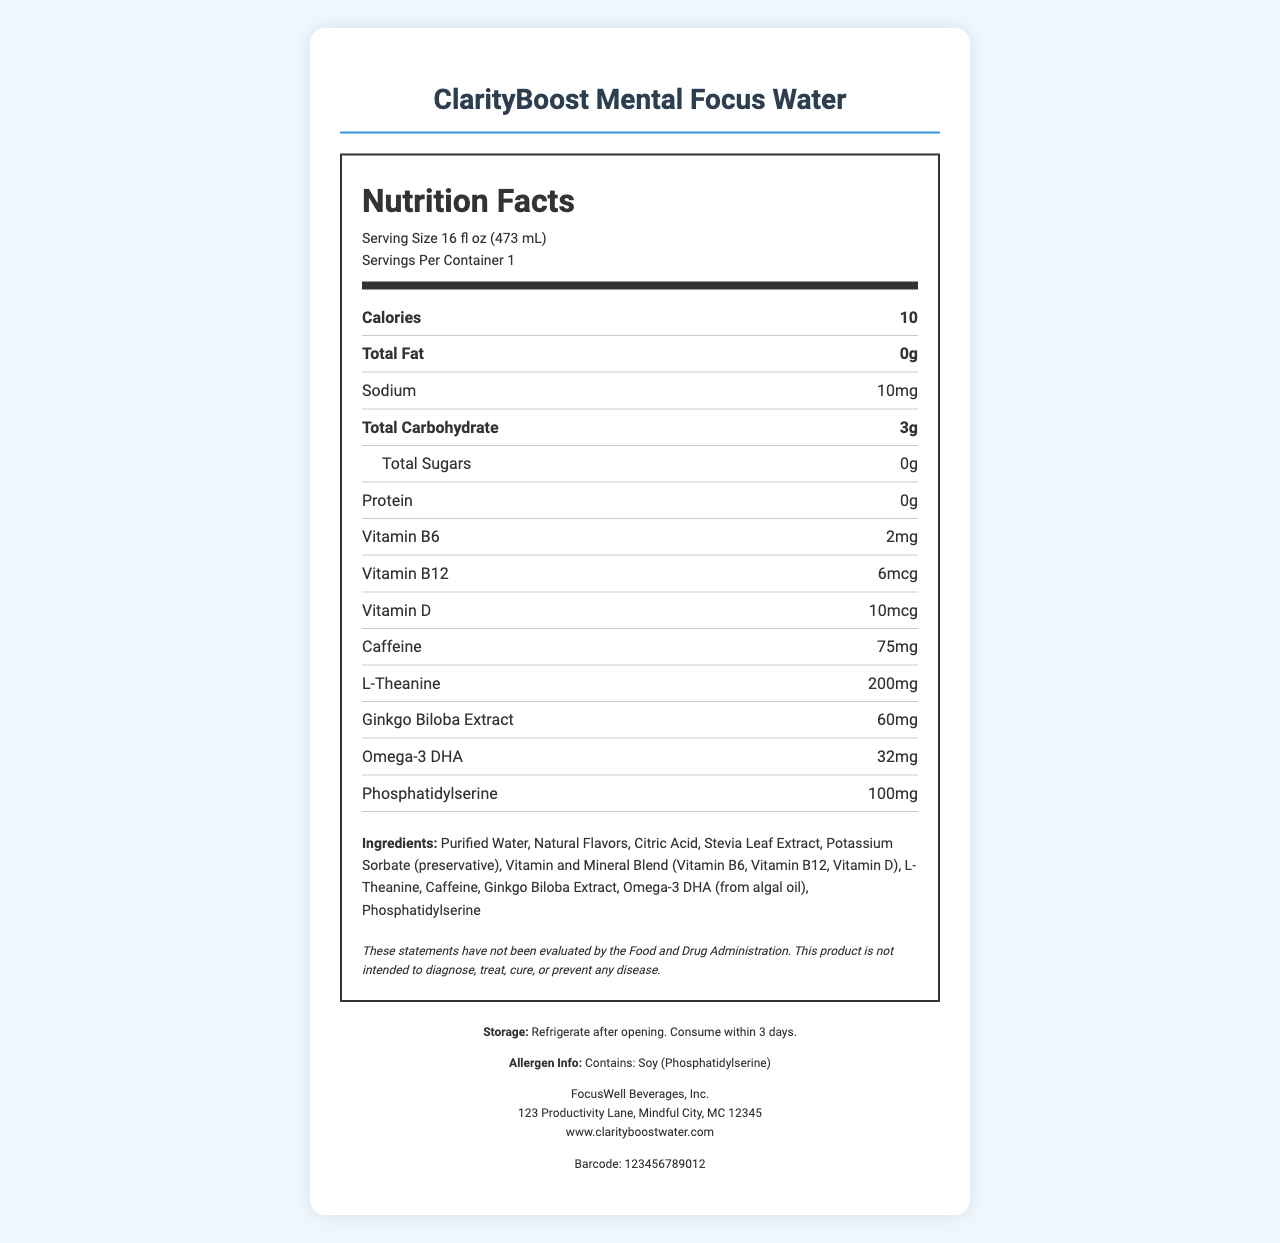what is the serving size for ClarityBoost Mental Focus Water? The serving size is listed as 16 fl oz (473 mL) in the Nutrition Facts section of the document.
Answer: 16 fl oz (473 mL) how many calories are in a serving of ClarityBoost Mental Focus Water? The document specifies that each serving contains 10 calories.
Answer: 10 how much caffeine does the product contain? The Nutrition Facts section clearly indicates that the product contains 75mg of caffeine.
Answer: 75mg what ingredients are present in the vitamin and mineral blend? The description under ingredients lists Vitamin B6, Vitamin B12, and Vitamin D as part of the vitamin and mineral blend.
Answer: Vitamin B6, Vitamin B12, Vitamin D what is the sodium content per serving? The document shows that the sodium content is 10mg per serving.
Answer: 10mg which vitamins are included in the product? A. Vitamin A, Vitamin C B. Vitamin B6, Vitamin B12, Vitamin D C. Vitamin E, Vitamin K According to the nutrition label, the product includes Vitamin B6, Vitamin B12, and Vitamin D.
Answer: B how many grams of total sugars are present in the product? The Nutrition Facts section lists the total sugars as 0g.
Answer: 0g what preservative is used in the product? A. Sodium Benzoate B. Potassium Sorbate C. Calcium Propionate D. Ascorbic Acid The ingredients list mentions Potassium Sorbate as the preservative used.
Answer: B does the product contain any protein? The Nutrition Facts state that the product contains 0g of protein, indicating it does not contain any protein.
Answer: No are there any allergens in ClarityBoost Mental Focus Water? The allergen information states that the product contains soy (Phosphatidylserine).
Answer: Yes provide a summary of the document. The document includes nutrition information, ingredients, calorie content, allergens, storage instructions, and manufacturer details for the ClarityBoost Mental Focus Water.
Answer: The document is a Nutrition Facts Label for ClarityBoost Mental Focus Water by FocusWell Beverages, Inc. It specifies a serving size of 16 fl oz, 10 calories, 75mg caffeine, 200mg L-Theanine, and various vitamins and other ingredients aimed at enhancing mental clarity and focus. The product contains soy and should be refrigerated after opening. what is the storage recommendation after opening the product? The document specifies that the product should be refrigerated after opening and consumed within 3 days.
Answer: Refrigerate after opening. Consume within 3 days. why is the product not intended to diagnose, treat, cure, or prevent any disease? The disclaimer states this but does not provide further details on why the product is not intended for these purposes.
Answer: Not enough information how many servings are in one container of the product? The Nutrition Facts section lists that there is 1 serving per container.
Answer: 1 who is the manufacturer of ClarityBoost Mental Focus Water? The manufacturer is listed at the bottom of the document as FocusWell Beverages, Inc.
Answer: FocusWell Beverages, Inc. 